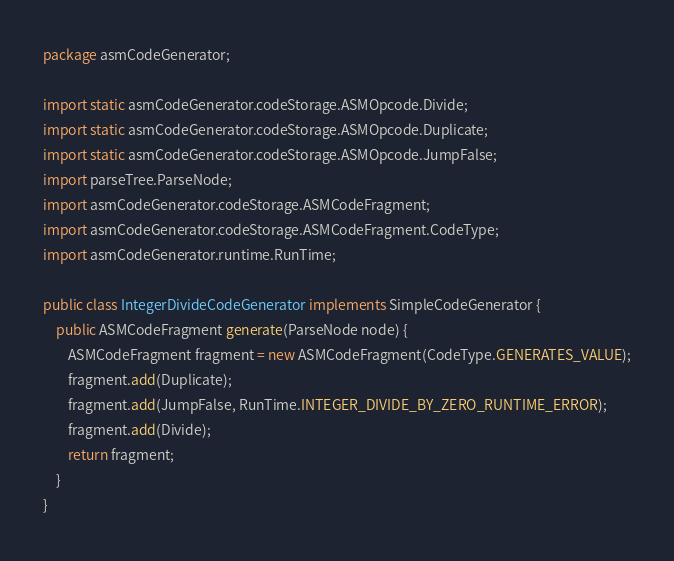Convert code to text. <code><loc_0><loc_0><loc_500><loc_500><_Java_>package asmCodeGenerator;

import static asmCodeGenerator.codeStorage.ASMOpcode.Divide;
import static asmCodeGenerator.codeStorage.ASMOpcode.Duplicate;
import static asmCodeGenerator.codeStorage.ASMOpcode.JumpFalse;
import parseTree.ParseNode;
import asmCodeGenerator.codeStorage.ASMCodeFragment;
import asmCodeGenerator.codeStorage.ASMCodeFragment.CodeType;
import asmCodeGenerator.runtime.RunTime;

public class IntegerDivideCodeGenerator implements SimpleCodeGenerator {
	public ASMCodeFragment generate(ParseNode node) {
		ASMCodeFragment fragment = new ASMCodeFragment(CodeType.GENERATES_VALUE);
		fragment.add(Duplicate);
		fragment.add(JumpFalse, RunTime.INTEGER_DIVIDE_BY_ZERO_RUNTIME_ERROR);
		fragment.add(Divide);
		return fragment;
	}
}
</code> 